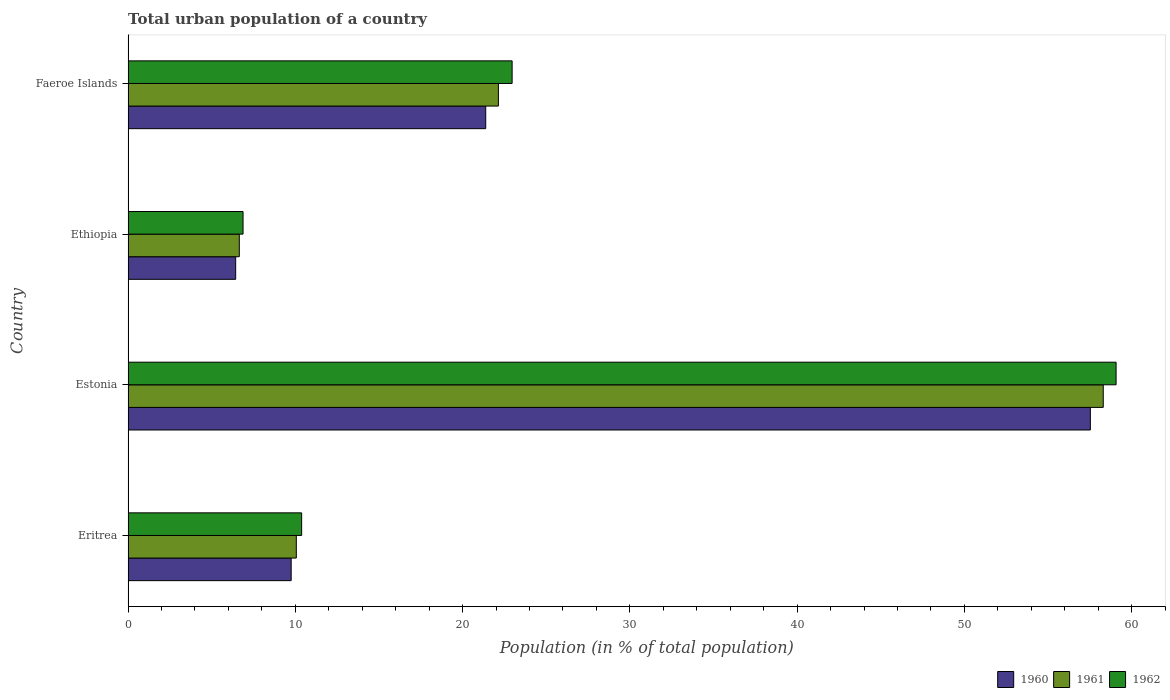Are the number of bars on each tick of the Y-axis equal?
Keep it short and to the point. Yes. How many bars are there on the 3rd tick from the bottom?
Your answer should be very brief. 3. What is the label of the 3rd group of bars from the top?
Offer a very short reply. Estonia. What is the urban population in 1961 in Estonia?
Keep it short and to the point. 58.3. Across all countries, what is the maximum urban population in 1960?
Make the answer very short. 57.53. Across all countries, what is the minimum urban population in 1961?
Ensure brevity in your answer.  6.65. In which country was the urban population in 1960 maximum?
Make the answer very short. Estonia. In which country was the urban population in 1962 minimum?
Provide a short and direct response. Ethiopia. What is the total urban population in 1961 in the graph?
Your answer should be very brief. 97.15. What is the difference between the urban population in 1962 in Eritrea and that in Estonia?
Provide a succinct answer. -48.7. What is the difference between the urban population in 1962 in Estonia and the urban population in 1961 in Ethiopia?
Make the answer very short. 52.42. What is the average urban population in 1961 per country?
Give a very brief answer. 24.29. What is the difference between the urban population in 1961 and urban population in 1962 in Faeroe Islands?
Provide a short and direct response. -0.82. What is the ratio of the urban population in 1960 in Eritrea to that in Faeroe Islands?
Your response must be concise. 0.46. Is the urban population in 1962 in Eritrea less than that in Estonia?
Ensure brevity in your answer.  Yes. What is the difference between the highest and the second highest urban population in 1961?
Keep it short and to the point. 36.16. What is the difference between the highest and the lowest urban population in 1962?
Your answer should be compact. 52.2. In how many countries, is the urban population in 1962 greater than the average urban population in 1962 taken over all countries?
Ensure brevity in your answer.  1. What does the 1st bar from the top in Estonia represents?
Keep it short and to the point. 1962. What does the 3rd bar from the bottom in Ethiopia represents?
Give a very brief answer. 1962. Is it the case that in every country, the sum of the urban population in 1960 and urban population in 1961 is greater than the urban population in 1962?
Make the answer very short. Yes. Are all the bars in the graph horizontal?
Ensure brevity in your answer.  Yes. What is the difference between two consecutive major ticks on the X-axis?
Make the answer very short. 10. Are the values on the major ticks of X-axis written in scientific E-notation?
Your answer should be compact. No. Where does the legend appear in the graph?
Offer a very short reply. Bottom right. How many legend labels are there?
Ensure brevity in your answer.  3. What is the title of the graph?
Give a very brief answer. Total urban population of a country. Does "1971" appear as one of the legend labels in the graph?
Give a very brief answer. No. What is the label or title of the X-axis?
Offer a terse response. Population (in % of total population). What is the Population (in % of total population) of 1960 in Eritrea?
Keep it short and to the point. 9.75. What is the Population (in % of total population) of 1961 in Eritrea?
Give a very brief answer. 10.06. What is the Population (in % of total population) of 1962 in Eritrea?
Give a very brief answer. 10.38. What is the Population (in % of total population) of 1960 in Estonia?
Keep it short and to the point. 57.53. What is the Population (in % of total population) in 1961 in Estonia?
Give a very brief answer. 58.3. What is the Population (in % of total population) in 1962 in Estonia?
Keep it short and to the point. 59.07. What is the Population (in % of total population) of 1960 in Ethiopia?
Ensure brevity in your answer.  6.43. What is the Population (in % of total population) of 1961 in Ethiopia?
Give a very brief answer. 6.65. What is the Population (in % of total population) in 1962 in Ethiopia?
Offer a terse response. 6.87. What is the Population (in % of total population) in 1960 in Faeroe Islands?
Give a very brief answer. 21.38. What is the Population (in % of total population) of 1961 in Faeroe Islands?
Make the answer very short. 22.14. What is the Population (in % of total population) of 1962 in Faeroe Islands?
Keep it short and to the point. 22.96. Across all countries, what is the maximum Population (in % of total population) in 1960?
Your answer should be compact. 57.53. Across all countries, what is the maximum Population (in % of total population) in 1961?
Your response must be concise. 58.3. Across all countries, what is the maximum Population (in % of total population) in 1962?
Give a very brief answer. 59.07. Across all countries, what is the minimum Population (in % of total population) of 1960?
Keep it short and to the point. 6.43. Across all countries, what is the minimum Population (in % of total population) of 1961?
Provide a short and direct response. 6.65. Across all countries, what is the minimum Population (in % of total population) in 1962?
Provide a short and direct response. 6.87. What is the total Population (in % of total population) of 1960 in the graph?
Ensure brevity in your answer.  95.1. What is the total Population (in % of total population) of 1961 in the graph?
Keep it short and to the point. 97.15. What is the total Population (in % of total population) in 1962 in the graph?
Keep it short and to the point. 99.28. What is the difference between the Population (in % of total population) in 1960 in Eritrea and that in Estonia?
Your answer should be very brief. -47.78. What is the difference between the Population (in % of total population) in 1961 in Eritrea and that in Estonia?
Your answer should be compact. -48.24. What is the difference between the Population (in % of total population) in 1962 in Eritrea and that in Estonia?
Ensure brevity in your answer.  -48.7. What is the difference between the Population (in % of total population) of 1960 in Eritrea and that in Ethiopia?
Ensure brevity in your answer.  3.32. What is the difference between the Population (in % of total population) in 1961 in Eritrea and that in Ethiopia?
Provide a succinct answer. 3.41. What is the difference between the Population (in % of total population) of 1962 in Eritrea and that in Ethiopia?
Provide a succinct answer. 3.5. What is the difference between the Population (in % of total population) in 1960 in Eritrea and that in Faeroe Islands?
Your response must be concise. -11.63. What is the difference between the Population (in % of total population) in 1961 in Eritrea and that in Faeroe Islands?
Your response must be concise. -12.08. What is the difference between the Population (in % of total population) in 1962 in Eritrea and that in Faeroe Islands?
Your answer should be compact. -12.59. What is the difference between the Population (in % of total population) of 1960 in Estonia and that in Ethiopia?
Your answer should be compact. 51.1. What is the difference between the Population (in % of total population) of 1961 in Estonia and that in Ethiopia?
Offer a very short reply. 51.65. What is the difference between the Population (in % of total population) of 1962 in Estonia and that in Ethiopia?
Provide a short and direct response. 52.2. What is the difference between the Population (in % of total population) in 1960 in Estonia and that in Faeroe Islands?
Offer a very short reply. 36.15. What is the difference between the Population (in % of total population) in 1961 in Estonia and that in Faeroe Islands?
Offer a very short reply. 36.16. What is the difference between the Population (in % of total population) of 1962 in Estonia and that in Faeroe Islands?
Make the answer very short. 36.11. What is the difference between the Population (in % of total population) in 1960 in Ethiopia and that in Faeroe Islands?
Give a very brief answer. -14.95. What is the difference between the Population (in % of total population) of 1961 in Ethiopia and that in Faeroe Islands?
Keep it short and to the point. -15.49. What is the difference between the Population (in % of total population) in 1962 in Ethiopia and that in Faeroe Islands?
Keep it short and to the point. -16.09. What is the difference between the Population (in % of total population) of 1960 in Eritrea and the Population (in % of total population) of 1961 in Estonia?
Make the answer very short. -48.55. What is the difference between the Population (in % of total population) in 1960 in Eritrea and the Population (in % of total population) in 1962 in Estonia?
Offer a very short reply. -49.32. What is the difference between the Population (in % of total population) of 1961 in Eritrea and the Population (in % of total population) of 1962 in Estonia?
Provide a short and direct response. -49.01. What is the difference between the Population (in % of total population) in 1960 in Eritrea and the Population (in % of total population) in 1961 in Ethiopia?
Keep it short and to the point. 3.1. What is the difference between the Population (in % of total population) in 1960 in Eritrea and the Population (in % of total population) in 1962 in Ethiopia?
Offer a terse response. 2.88. What is the difference between the Population (in % of total population) of 1961 in Eritrea and the Population (in % of total population) of 1962 in Ethiopia?
Keep it short and to the point. 3.19. What is the difference between the Population (in % of total population) in 1960 in Eritrea and the Population (in % of total population) in 1961 in Faeroe Islands?
Offer a terse response. -12.39. What is the difference between the Population (in % of total population) in 1960 in Eritrea and the Population (in % of total population) in 1962 in Faeroe Islands?
Give a very brief answer. -13.21. What is the difference between the Population (in % of total population) in 1961 in Eritrea and the Population (in % of total population) in 1962 in Faeroe Islands?
Offer a terse response. -12.9. What is the difference between the Population (in % of total population) of 1960 in Estonia and the Population (in % of total population) of 1961 in Ethiopia?
Offer a terse response. 50.88. What is the difference between the Population (in % of total population) of 1960 in Estonia and the Population (in % of total population) of 1962 in Ethiopia?
Keep it short and to the point. 50.66. What is the difference between the Population (in % of total population) in 1961 in Estonia and the Population (in % of total population) in 1962 in Ethiopia?
Your answer should be compact. 51.43. What is the difference between the Population (in % of total population) of 1960 in Estonia and the Population (in % of total population) of 1961 in Faeroe Islands?
Your answer should be very brief. 35.39. What is the difference between the Population (in % of total population) in 1960 in Estonia and the Population (in % of total population) in 1962 in Faeroe Islands?
Your answer should be compact. 34.57. What is the difference between the Population (in % of total population) of 1961 in Estonia and the Population (in % of total population) of 1962 in Faeroe Islands?
Your answer should be compact. 35.34. What is the difference between the Population (in % of total population) of 1960 in Ethiopia and the Population (in % of total population) of 1961 in Faeroe Islands?
Give a very brief answer. -15.71. What is the difference between the Population (in % of total population) of 1960 in Ethiopia and the Population (in % of total population) of 1962 in Faeroe Islands?
Your answer should be very brief. -16.53. What is the difference between the Population (in % of total population) in 1961 in Ethiopia and the Population (in % of total population) in 1962 in Faeroe Islands?
Provide a succinct answer. -16.31. What is the average Population (in % of total population) of 1960 per country?
Your answer should be compact. 23.77. What is the average Population (in % of total population) in 1961 per country?
Keep it short and to the point. 24.29. What is the average Population (in % of total population) of 1962 per country?
Ensure brevity in your answer.  24.82. What is the difference between the Population (in % of total population) of 1960 and Population (in % of total population) of 1961 in Eritrea?
Provide a succinct answer. -0.31. What is the difference between the Population (in % of total population) in 1960 and Population (in % of total population) in 1962 in Eritrea?
Your response must be concise. -0.63. What is the difference between the Population (in % of total population) in 1961 and Population (in % of total population) in 1962 in Eritrea?
Your response must be concise. -0.32. What is the difference between the Population (in % of total population) of 1960 and Population (in % of total population) of 1961 in Estonia?
Ensure brevity in your answer.  -0.77. What is the difference between the Population (in % of total population) in 1960 and Population (in % of total population) in 1962 in Estonia?
Make the answer very short. -1.54. What is the difference between the Population (in % of total population) in 1961 and Population (in % of total population) in 1962 in Estonia?
Your answer should be very brief. -0.77. What is the difference between the Population (in % of total population) of 1960 and Population (in % of total population) of 1961 in Ethiopia?
Your response must be concise. -0.22. What is the difference between the Population (in % of total population) in 1960 and Population (in % of total population) in 1962 in Ethiopia?
Provide a succinct answer. -0.44. What is the difference between the Population (in % of total population) of 1961 and Population (in % of total population) of 1962 in Ethiopia?
Make the answer very short. -0.22. What is the difference between the Population (in % of total population) in 1960 and Population (in % of total population) in 1961 in Faeroe Islands?
Your response must be concise. -0.76. What is the difference between the Population (in % of total population) of 1960 and Population (in % of total population) of 1962 in Faeroe Islands?
Your answer should be compact. -1.58. What is the difference between the Population (in % of total population) of 1961 and Population (in % of total population) of 1962 in Faeroe Islands?
Give a very brief answer. -0.82. What is the ratio of the Population (in % of total population) in 1960 in Eritrea to that in Estonia?
Your answer should be very brief. 0.17. What is the ratio of the Population (in % of total population) in 1961 in Eritrea to that in Estonia?
Keep it short and to the point. 0.17. What is the ratio of the Population (in % of total population) in 1962 in Eritrea to that in Estonia?
Your response must be concise. 0.18. What is the ratio of the Population (in % of total population) of 1960 in Eritrea to that in Ethiopia?
Offer a terse response. 1.52. What is the ratio of the Population (in % of total population) of 1961 in Eritrea to that in Ethiopia?
Provide a short and direct response. 1.51. What is the ratio of the Population (in % of total population) of 1962 in Eritrea to that in Ethiopia?
Keep it short and to the point. 1.51. What is the ratio of the Population (in % of total population) in 1960 in Eritrea to that in Faeroe Islands?
Offer a terse response. 0.46. What is the ratio of the Population (in % of total population) of 1961 in Eritrea to that in Faeroe Islands?
Your answer should be compact. 0.45. What is the ratio of the Population (in % of total population) in 1962 in Eritrea to that in Faeroe Islands?
Keep it short and to the point. 0.45. What is the ratio of the Population (in % of total population) of 1960 in Estonia to that in Ethiopia?
Provide a short and direct response. 8.94. What is the ratio of the Population (in % of total population) in 1961 in Estonia to that in Ethiopia?
Make the answer very short. 8.77. What is the ratio of the Population (in % of total population) in 1962 in Estonia to that in Ethiopia?
Your answer should be very brief. 8.59. What is the ratio of the Population (in % of total population) of 1960 in Estonia to that in Faeroe Islands?
Give a very brief answer. 2.69. What is the ratio of the Population (in % of total population) of 1961 in Estonia to that in Faeroe Islands?
Your answer should be compact. 2.63. What is the ratio of the Population (in % of total population) of 1962 in Estonia to that in Faeroe Islands?
Provide a short and direct response. 2.57. What is the ratio of the Population (in % of total population) in 1960 in Ethiopia to that in Faeroe Islands?
Offer a very short reply. 0.3. What is the ratio of the Population (in % of total population) of 1961 in Ethiopia to that in Faeroe Islands?
Make the answer very short. 0.3. What is the ratio of the Population (in % of total population) of 1962 in Ethiopia to that in Faeroe Islands?
Give a very brief answer. 0.3. What is the difference between the highest and the second highest Population (in % of total population) of 1960?
Your answer should be compact. 36.15. What is the difference between the highest and the second highest Population (in % of total population) of 1961?
Your response must be concise. 36.16. What is the difference between the highest and the second highest Population (in % of total population) in 1962?
Provide a short and direct response. 36.11. What is the difference between the highest and the lowest Population (in % of total population) of 1960?
Your response must be concise. 51.1. What is the difference between the highest and the lowest Population (in % of total population) of 1961?
Give a very brief answer. 51.65. What is the difference between the highest and the lowest Population (in % of total population) in 1962?
Your answer should be compact. 52.2. 